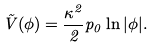<formula> <loc_0><loc_0><loc_500><loc_500>\tilde { V } ( \phi ) = \frac { \kappa ^ { 2 } } { 2 } p _ { 0 } \ln | \phi | .</formula> 